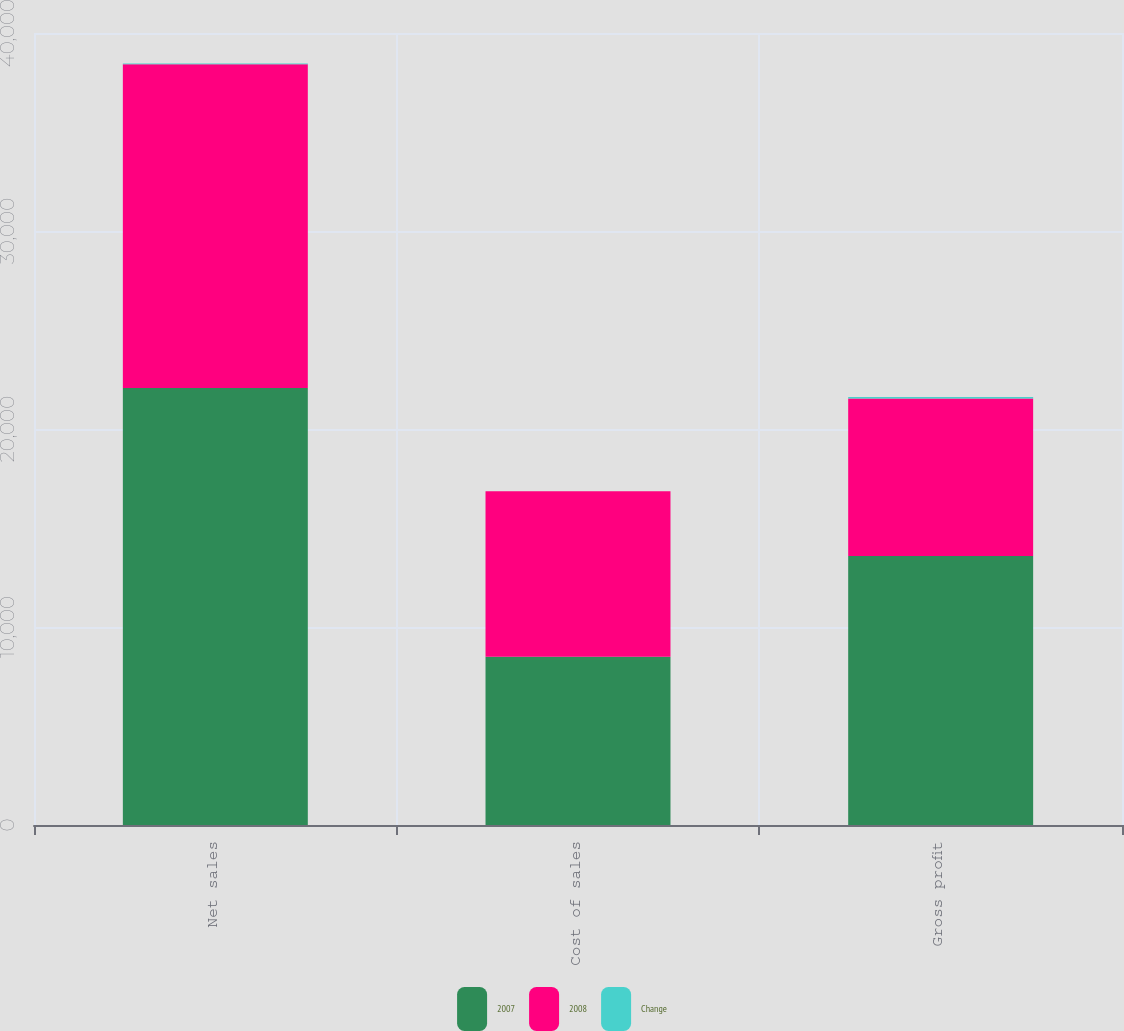Convert chart. <chart><loc_0><loc_0><loc_500><loc_500><stacked_bar_chart><ecel><fcel>Net sales<fcel>Cost of sales<fcel>Gross profit<nl><fcel>2007<fcel>22074<fcel>8492<fcel>13582<nl><fcel>2008<fcel>16345<fcel>8366<fcel>7959<nl><fcel>Change<fcel>35.1<fcel>1.3<fcel>70.6<nl></chart> 